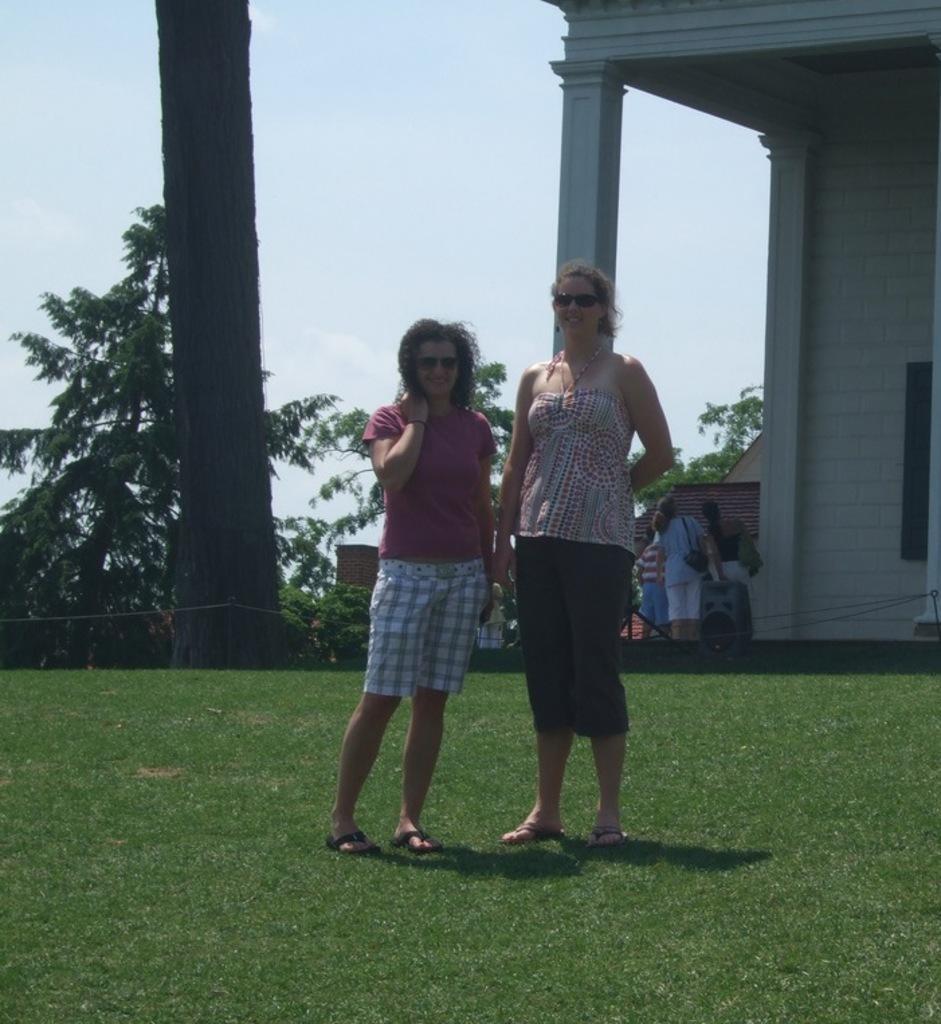Can you describe this image briefly? In this picture, we can see a few people, ground with grass, trees, plants, house, pillar, and the sky. 